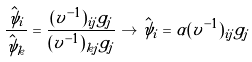Convert formula to latex. <formula><loc_0><loc_0><loc_500><loc_500>\frac { \hat { \psi } _ { i } } { \hat { \psi } _ { k } } = \frac { ( v ^ { - 1 } ) _ { i j } g _ { j } } { ( v ^ { - 1 } ) _ { k j } g _ { j } } \to \hat { \psi } _ { i } = \alpha ( v ^ { - 1 } ) _ { i j } g _ { j }</formula> 